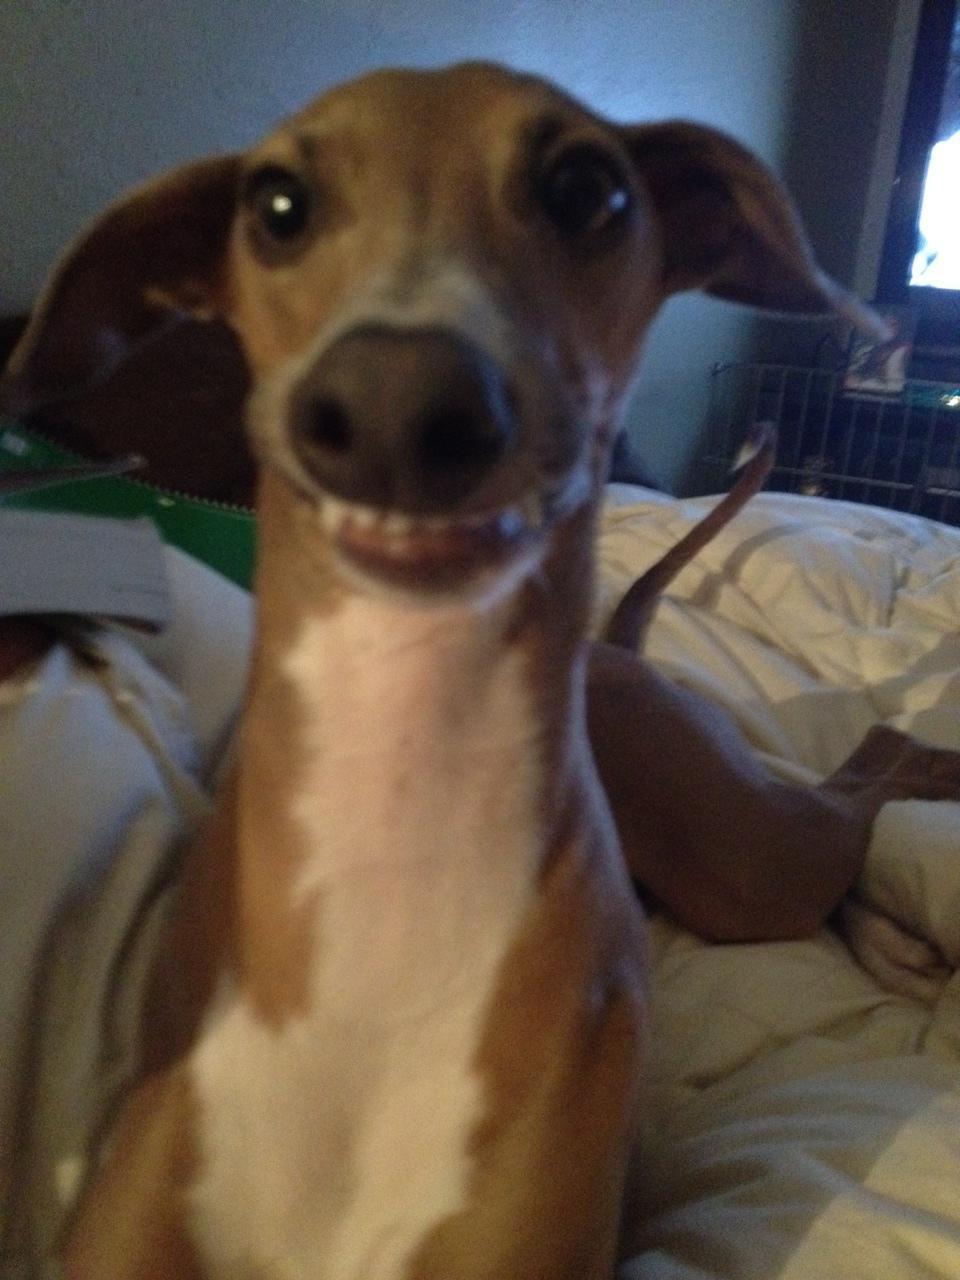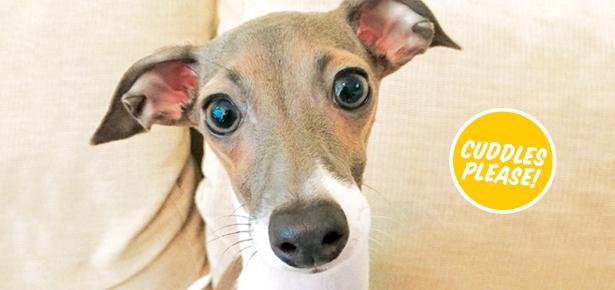The first image is the image on the left, the second image is the image on the right. Analyze the images presented: Is the assertion "An image shows a gray and white hound wearing a collar with a charm attached." valid? Answer yes or no. No. The first image is the image on the left, the second image is the image on the right. Given the left and right images, does the statement "In one image, a gray and white dog with ears that point to the side is wearing a collar with a dangling charm." hold true? Answer yes or no. No. 